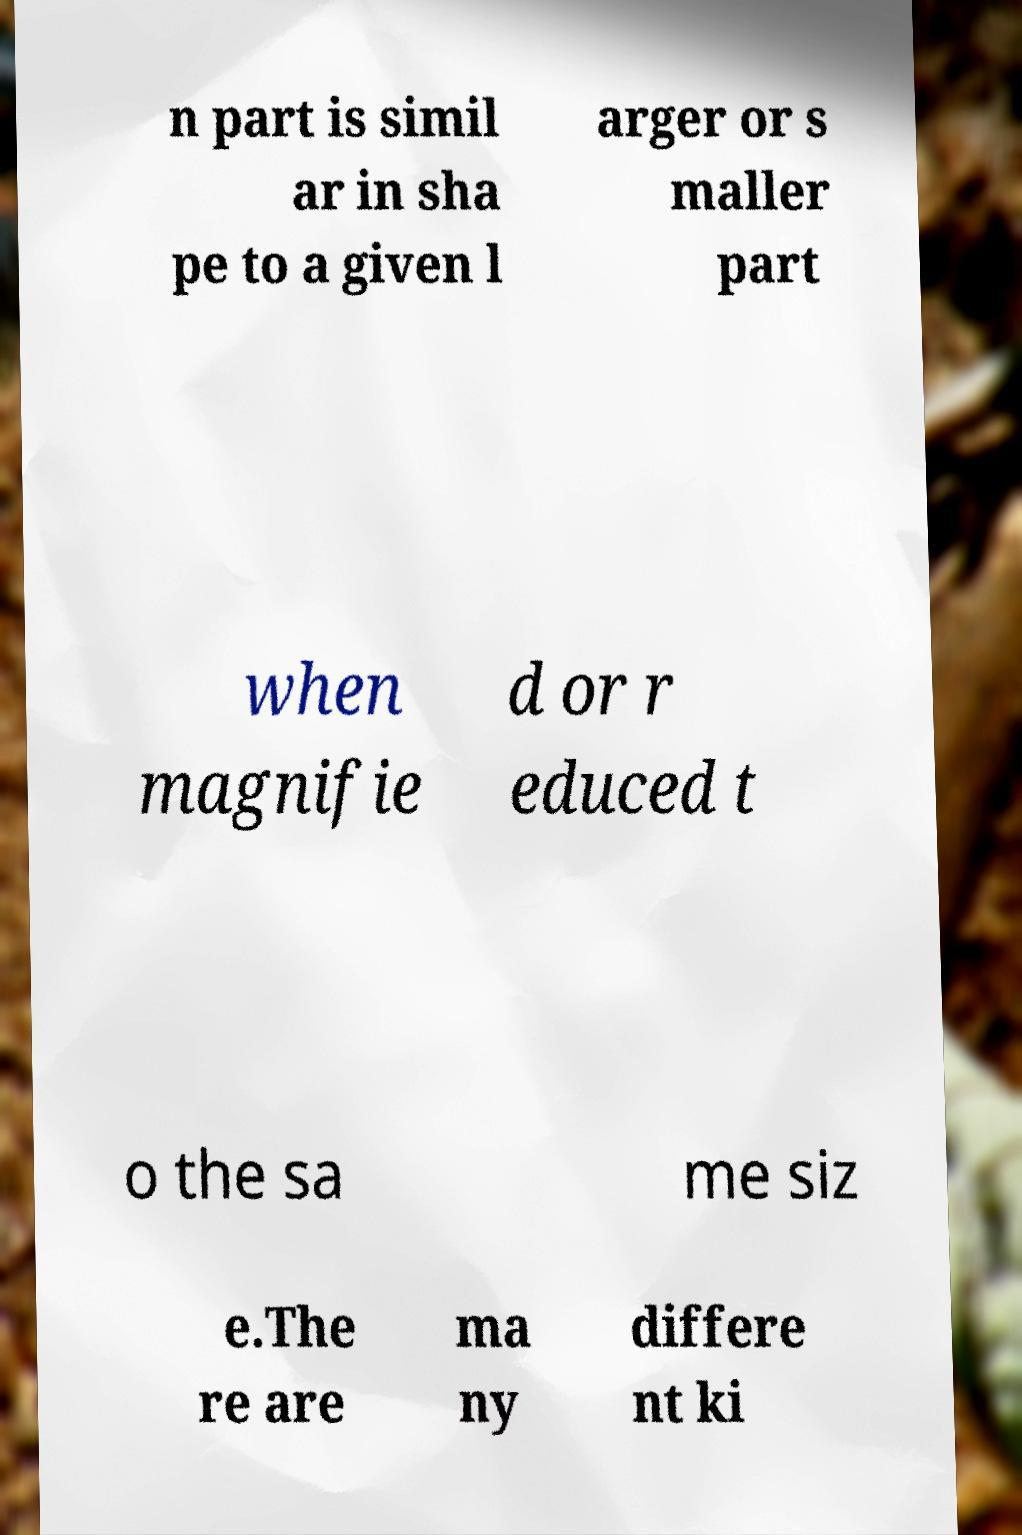Could you extract and type out the text from this image? n part is simil ar in sha pe to a given l arger or s maller part when magnifie d or r educed t o the sa me siz e.The re are ma ny differe nt ki 